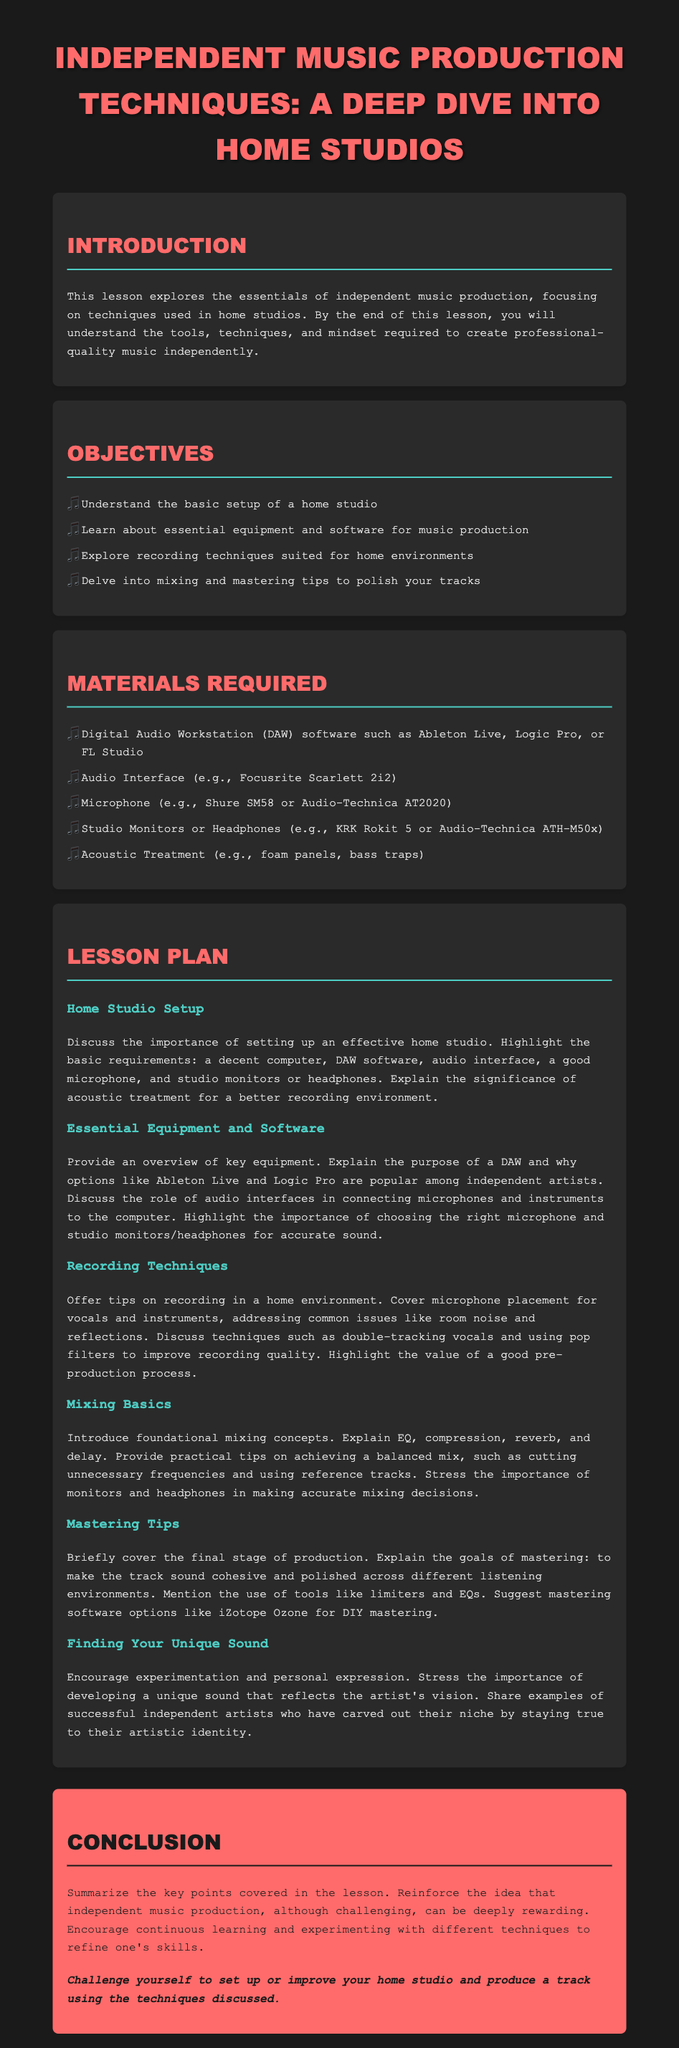what is the title of the lesson plan? The title is explicitly mentioned at the beginning of the document, stating the subject focus.
Answer: Independent Music Production Techniques: A Deep Dive into Home Studios how many objectives are listed? The document specifies a list of objectives in a bullet format, clearly indicating how many there are.
Answer: 4 which microphone is suggested in the materials required section? The materials required section includes specific equipment, including suggestions for microphones to use.
Answer: Shure SM58 or Audio-Technica AT2020 name one of the key roles of a DAW mentioned in the document. The document provides an overview of DAWs and describes their function in the music production process, focusing on their importance.
Answer: Music production what is one technique mentioned for improving recording quality? The lesson contains specific recording techniques to enhance sound quality during the production process.
Answer: Double-tracking what is the primary goal of mastering? The document briefly explains the objectives of the mastering process within music production.
Answer: Cohesive and polished sound what does the conclusion encourage artists to do? The conclusion section summarizes the learning and motivates artists toward a specific action related to their production efforts.
Answer: Set up or improve your home studio what color is used for the section headers? The document specifies the styling of headers, including the color used in the design.
Answer: #ff6b6b what is one software option suggested for mastering? The lesson provides recommendations for software tools that can be used for the mastering phase of music production.
Answer: iZotope Ozone 